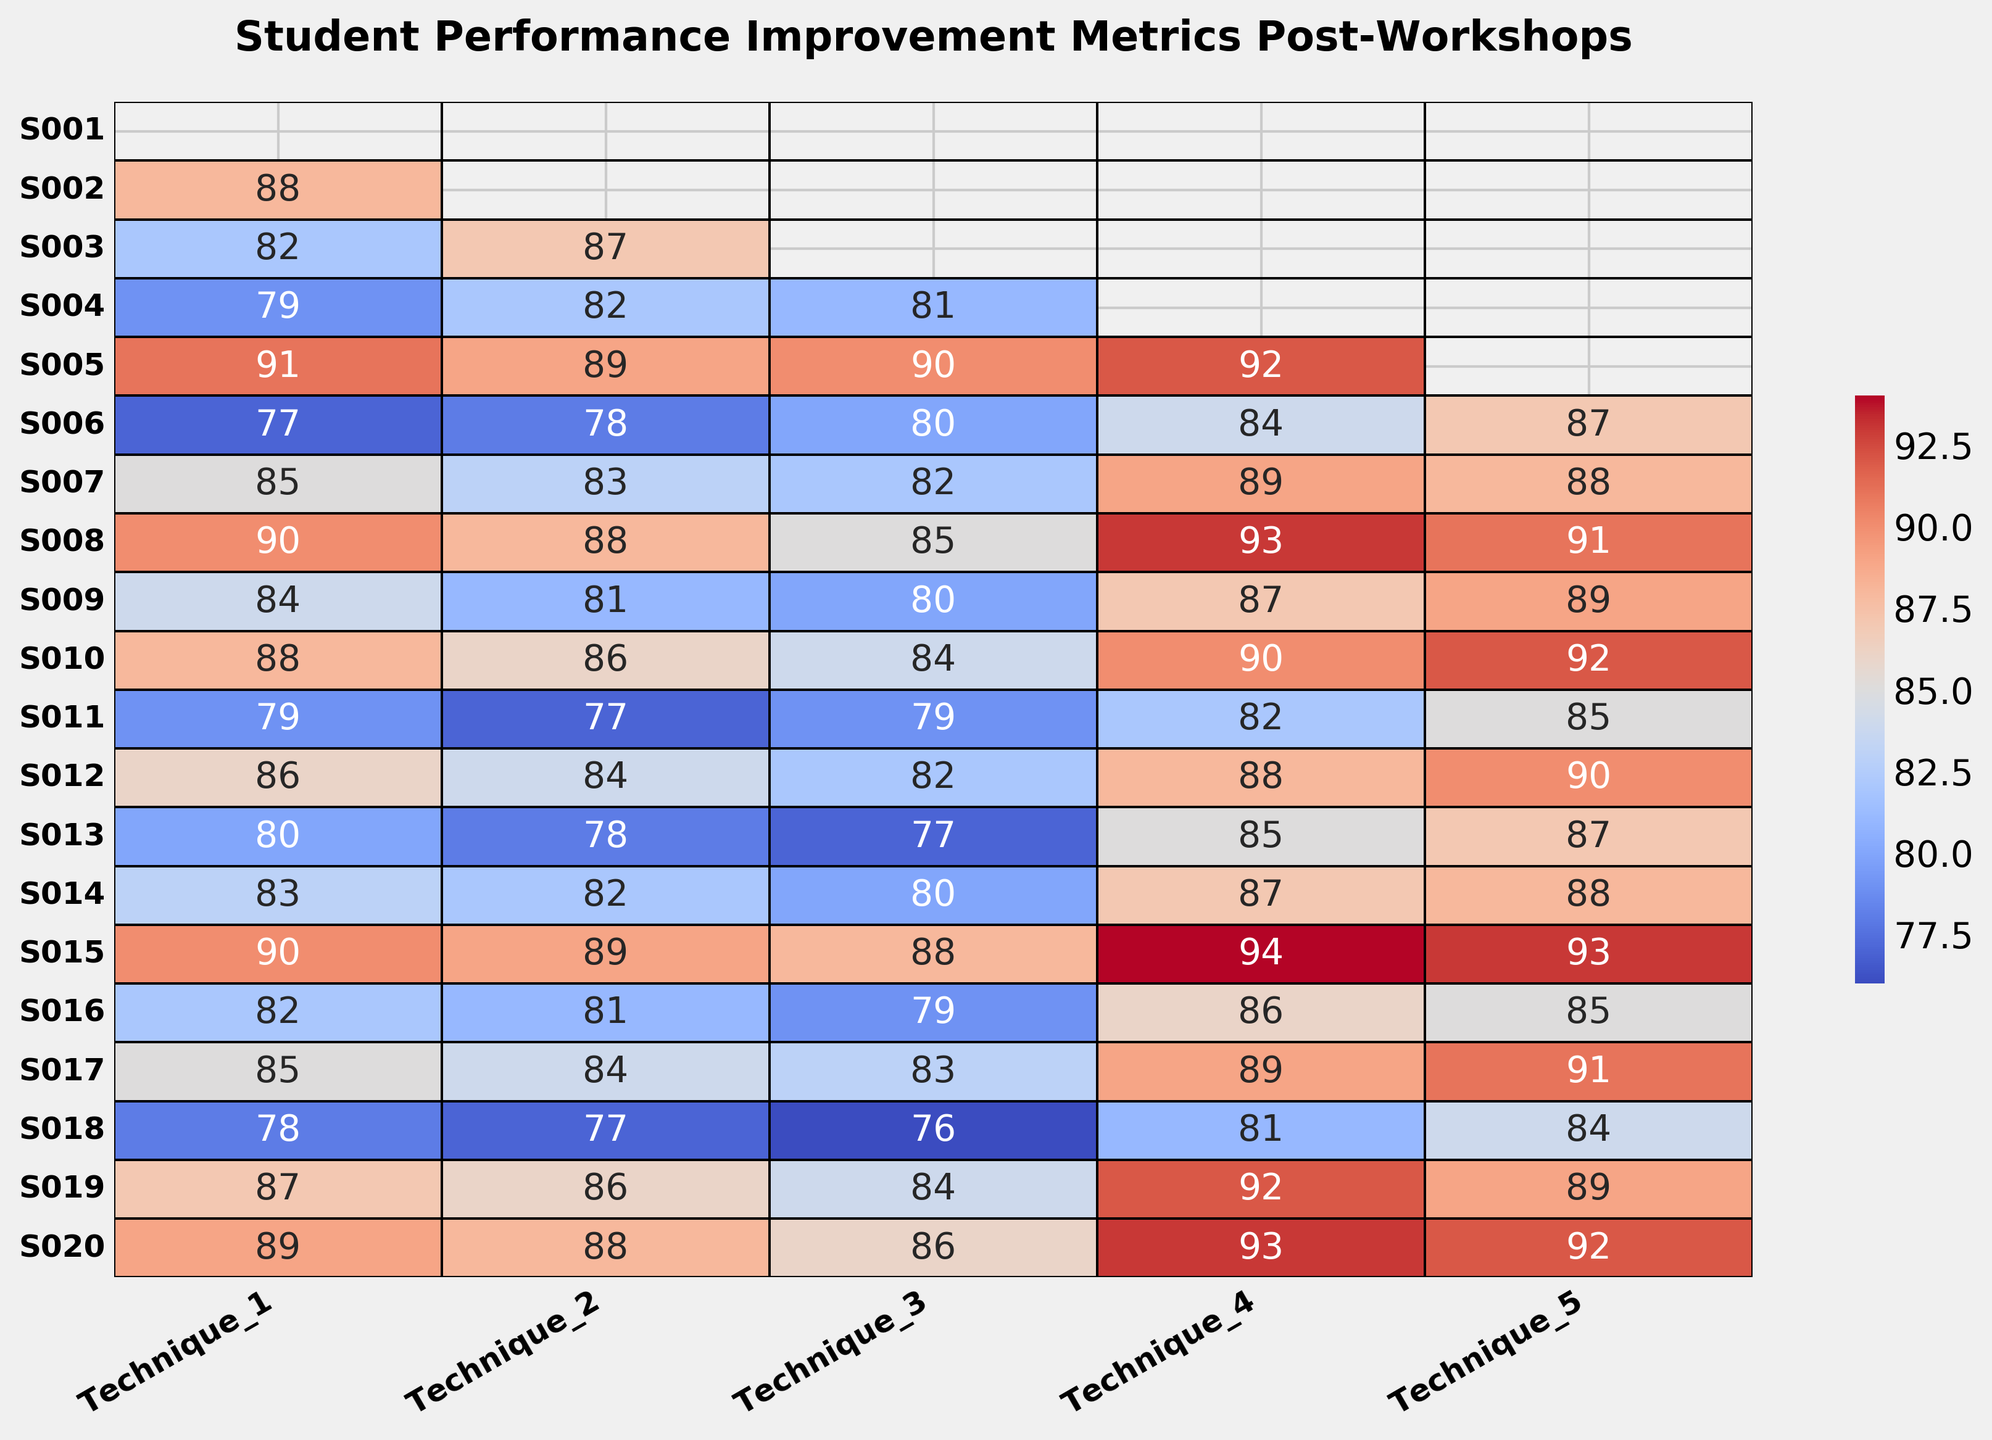What is the average performance improvement metric for Technique_1? To find the average performance improvement metric for Technique_1, sum all values in the Technique_1 column, which are 75 + 88 + 82 + 79 + 91 + 77 + 85 + 90 + 84 + 88 + 79 + 86 + 80 + 83 + 90 + 82 + 85 + 78 + 87 + 89. This equals 1669. Divide by the number of students (20) to get the average, 1669 / 20 = 83.45.
Answer: 83.45 Which student showed the highest performance improvement in Technique_5? By looking at the highest value in the Technique_5 column, we see that Student S005 has the highest performance improvement with a score of 95.
Answer: S005 Between Technique_3 and Technique_4, which one had more consistent improvement metrics among students? Consistency in performance can be inferred from the range (difference between maximum and minimum values). Technique_3 ranges from 76 to 90, a difference of 14, while Technique_4 ranges from 81 to 94, a difference of 13. Hence, Technique_4 has a slightly more consistent improvement range among students.
Answer: Technique_4 Which technique appears to have the most uniform color distribution, indicating similar performance across students? Uniform color across the heatmap indicates similar performance levels. Visual inspection shows that Technique_2 has a relatively uniform distribution of color across all students, indicating similar performance levels.
Answer: Technique_2 How many students have a performance improvement score of 90 or above in Technique_4? Count the number of cells in the Technique_4 column with a score of 90 or above. These scores are associated with students S003, S008, S015, S019, and S020. Therefore, 5 students meet this criterion.
Answer: 5 What is the difference between the highest and lowest performance improvement scores for Technique_1? The highest score in Technique_1 is 91 (S005), and the lowest is 75 (S001). The difference is 91 - 75, which equals 16.
Answer: 16 Which student shows the most overall improvement across all techniques? To determine the student with the most overall improvement, sum up the scores across all techniques for each student. For instance, S005 has scores of 91, 89, 90, 92, and 95, which total 457. Summing for all students, S005 has the highest total score.
Answer: S005 Compare the average performance improvement for Technique_3 and Technique_4. Which one is higher? Calculate the averages for both techniques. For Technique_3: sum all values and divide by 20, similarly for Technique_4. Technique_3’s average is (78 + 79 + 83 + 81 + 90 + 80 + 82 + 85 + 80 + 84 + 79 + 82 + 77 + 80 + 88 + 79 + 83 + 76 + 84 + 86) / 20 = 82.1. Technique_4’s average is (85 + 87 + 90 + 88 + 92 + 84 + 89 + 93 + 87 + 90 + 82 + 88 + 85 + 87 + 94 + 86 + 89 + 81 + 92 + 93) / 20 = 88.05. Therefore, Technique_4 has a higher average.
Answer: Technique_4 Based on the heatmap's color distribution, which technique seems to have the highest variation in student performance? Visual inspection reveals that Technique_1 shows a broader range of colors, indicating high variation in performance scores among students compared to other techniques.
Answer: Technique_1 